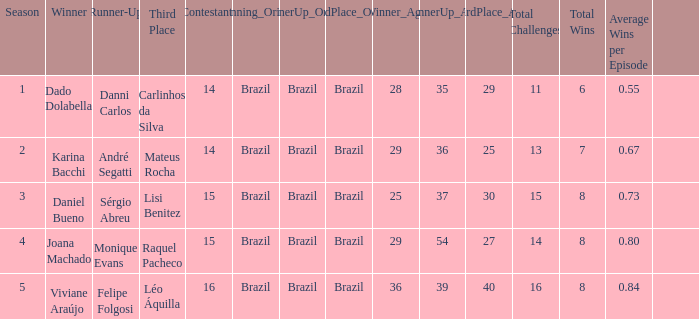In what season was the winner Dado Dolabella? 1.0. 